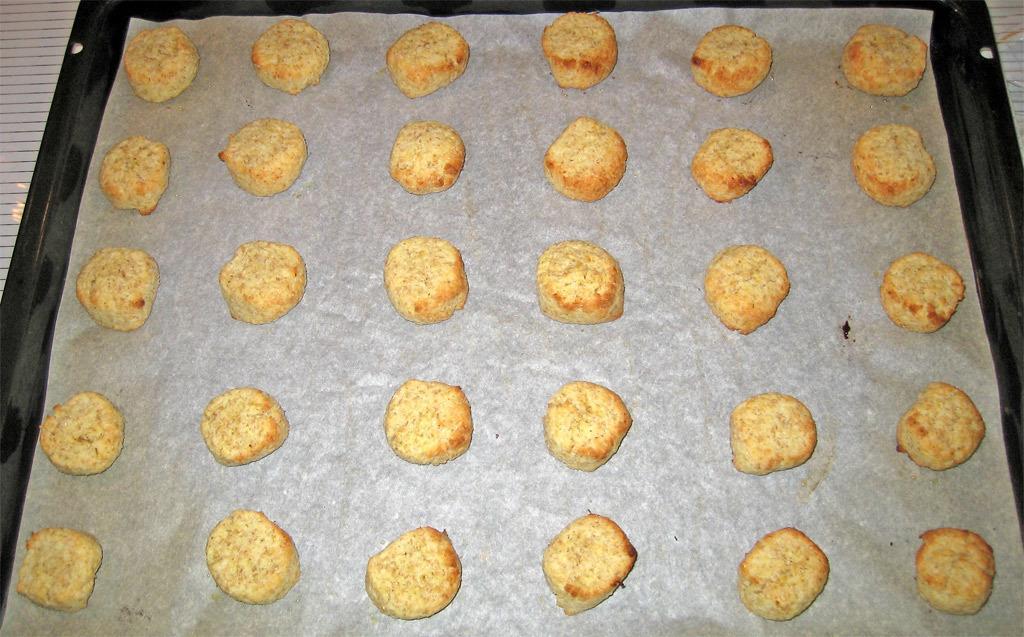In one or two sentences, can you explain what this image depicts? In the center of the image we can see one white color table. On the table, we can see one black color object. In the object, we can see one paper. On the paper, we can see some cookies, which are in cream and brown color. 